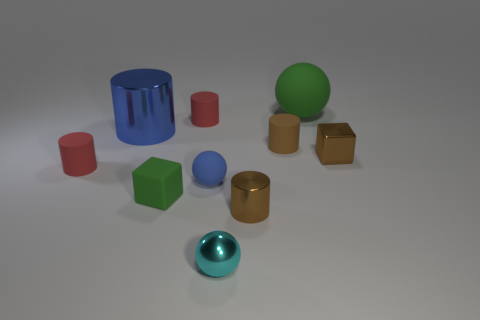Which objects in the image could fit inside the blue cylindrical container? Several smaller objects could fit inside the blue cylindrical container: the red, pink, and tiny brown cylinders, the green cube, and potentially the golden cylinders depending on their exact dimensions. 